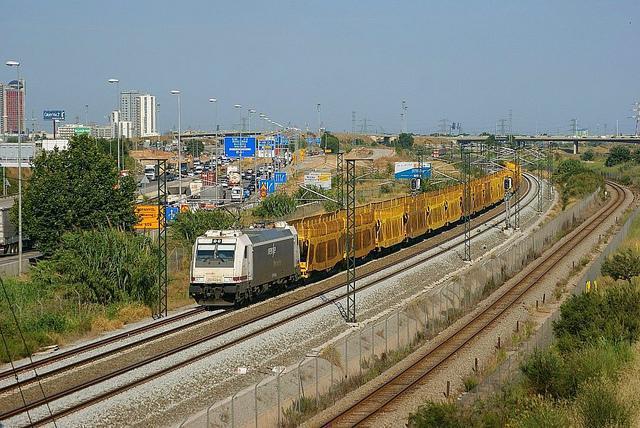How many train tracks?
Give a very brief answer. 3. 